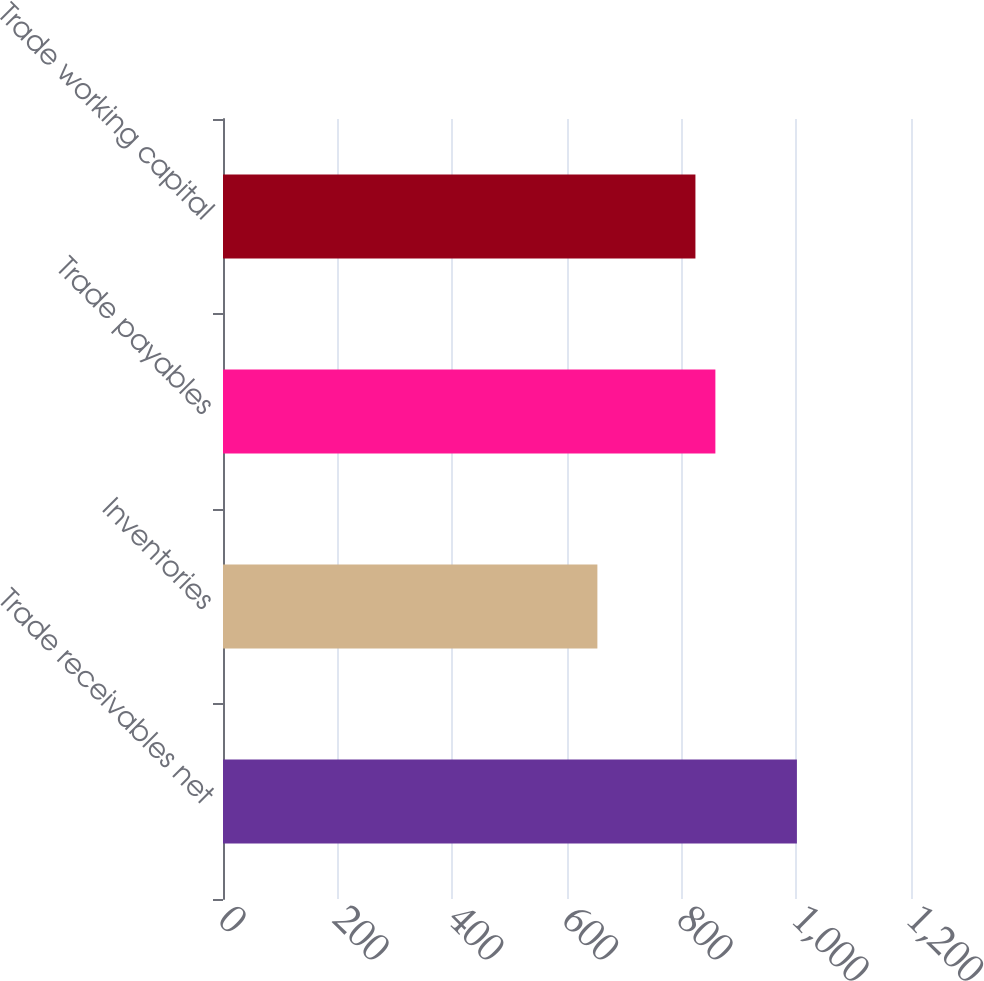<chart> <loc_0><loc_0><loc_500><loc_500><bar_chart><fcel>Trade receivables net<fcel>Inventories<fcel>Trade payables<fcel>Trade working capital<nl><fcel>1001<fcel>653<fcel>858.8<fcel>824<nl></chart> 